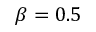<formula> <loc_0><loc_0><loc_500><loc_500>\beta = 0 . 5</formula> 